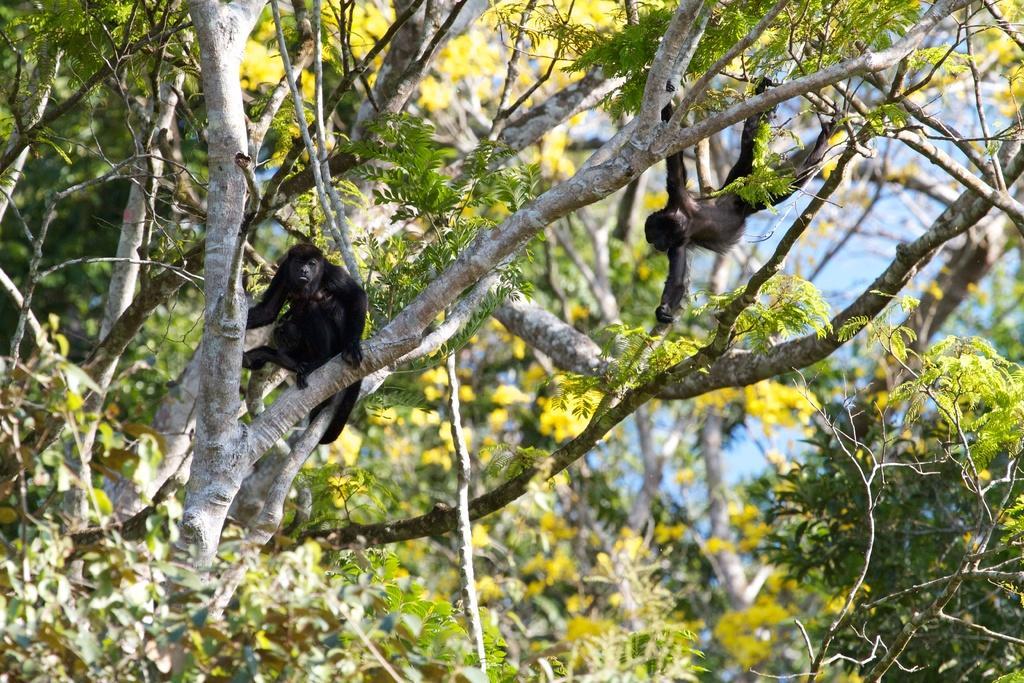Describe this image in one or two sentences. In this picture we can see apes on the branches of trees. In the background there is sky. 